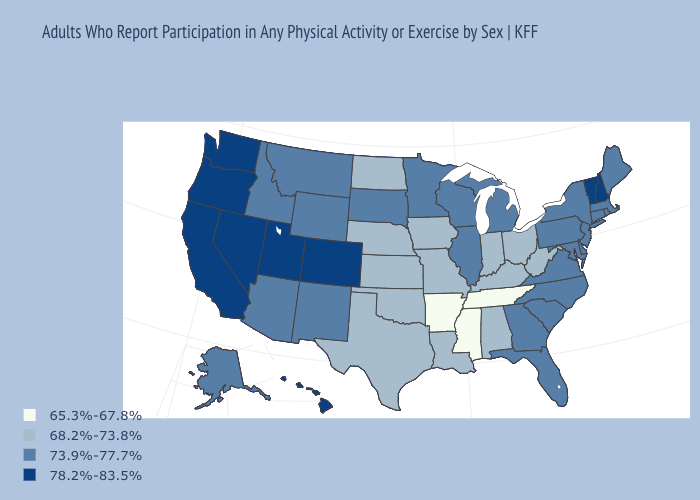Does Washington have the highest value in the USA?
Short answer required. Yes. Which states have the highest value in the USA?
Quick response, please. California, Colorado, Hawaii, Nevada, New Hampshire, Oregon, Utah, Vermont, Washington. Name the states that have a value in the range 73.9%-77.7%?
Keep it brief. Alaska, Arizona, Connecticut, Delaware, Florida, Georgia, Idaho, Illinois, Maine, Maryland, Massachusetts, Michigan, Minnesota, Montana, New Jersey, New Mexico, New York, North Carolina, Pennsylvania, Rhode Island, South Carolina, South Dakota, Virginia, Wisconsin, Wyoming. Does the first symbol in the legend represent the smallest category?
Give a very brief answer. Yes. What is the value of New York?
Short answer required. 73.9%-77.7%. Name the states that have a value in the range 73.9%-77.7%?
Give a very brief answer. Alaska, Arizona, Connecticut, Delaware, Florida, Georgia, Idaho, Illinois, Maine, Maryland, Massachusetts, Michigan, Minnesota, Montana, New Jersey, New Mexico, New York, North Carolina, Pennsylvania, Rhode Island, South Carolina, South Dakota, Virginia, Wisconsin, Wyoming. What is the value of Georgia?
Be succinct. 73.9%-77.7%. Is the legend a continuous bar?
Short answer required. No. Which states have the lowest value in the MidWest?
Concise answer only. Indiana, Iowa, Kansas, Missouri, Nebraska, North Dakota, Ohio. Does Alabama have a higher value than Mississippi?
Short answer required. Yes. How many symbols are there in the legend?
Give a very brief answer. 4. Name the states that have a value in the range 73.9%-77.7%?
Answer briefly. Alaska, Arizona, Connecticut, Delaware, Florida, Georgia, Idaho, Illinois, Maine, Maryland, Massachusetts, Michigan, Minnesota, Montana, New Jersey, New Mexico, New York, North Carolina, Pennsylvania, Rhode Island, South Carolina, South Dakota, Virginia, Wisconsin, Wyoming. What is the value of California?
Give a very brief answer. 78.2%-83.5%. Name the states that have a value in the range 78.2%-83.5%?
Quick response, please. California, Colorado, Hawaii, Nevada, New Hampshire, Oregon, Utah, Vermont, Washington. What is the value of Illinois?
Answer briefly. 73.9%-77.7%. 